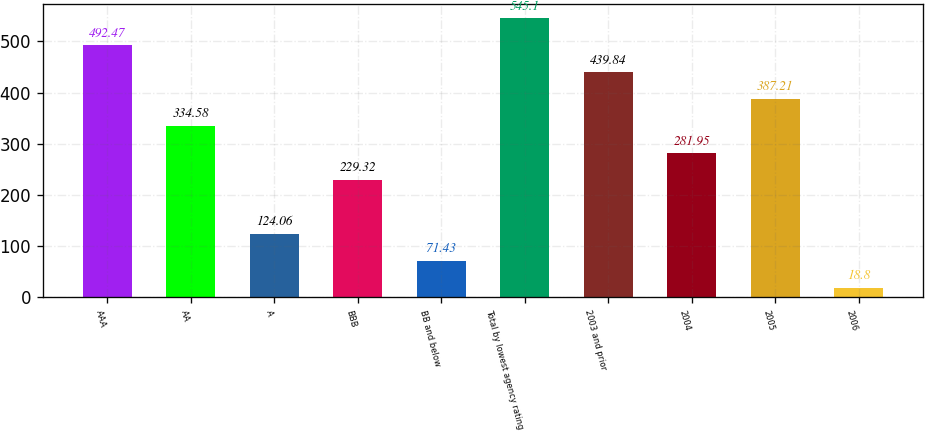Convert chart to OTSL. <chart><loc_0><loc_0><loc_500><loc_500><bar_chart><fcel>AAA<fcel>AA<fcel>A<fcel>BBB<fcel>BB and below<fcel>Total by lowest agency rating<fcel>2003 and prior<fcel>2004<fcel>2005<fcel>2006<nl><fcel>492.47<fcel>334.58<fcel>124.06<fcel>229.32<fcel>71.43<fcel>545.1<fcel>439.84<fcel>281.95<fcel>387.21<fcel>18.8<nl></chart> 